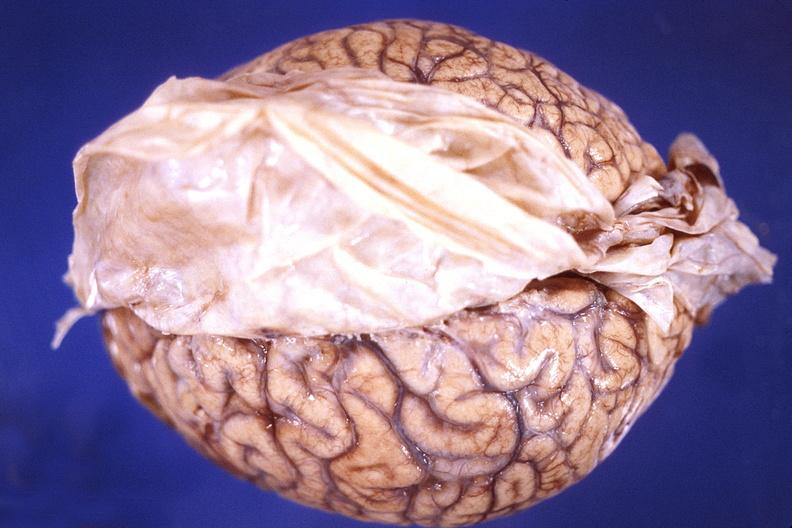s inflamed exocervix present?
Answer the question using a single word or phrase. No 